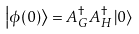Convert formula to latex. <formula><loc_0><loc_0><loc_500><loc_500>\left | \phi ( 0 ) \right > = A _ { G } ^ { \dag } A _ { H } ^ { \dag } \left | 0 \right ></formula> 